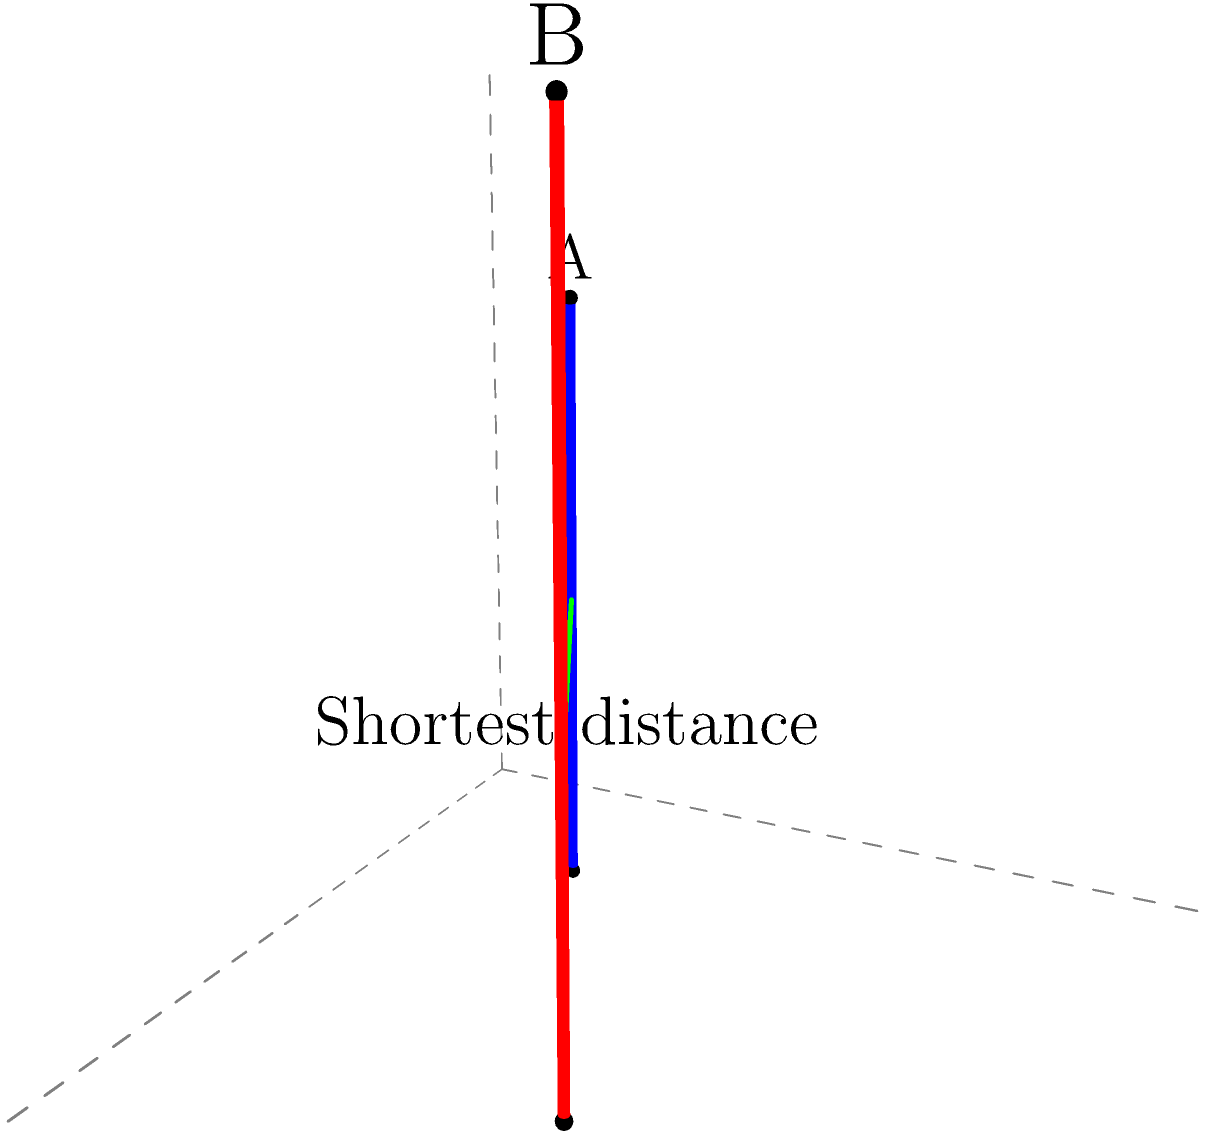Two skyscrapers, A and B, are represented as vertical line segments in a 3D coordinate system. Skyscraper A extends from $(1,1,0)$ to $(1,1,3)$, while skyscraper B extends from $(3,2,0)$ to $(3,2,4)$. What is the shortest distance between these two skyscrapers? To find the shortest distance between two vertical line segments in 3D space, we can follow these steps:

1) The shortest distance between two vertical line segments will always be horizontal, forming a right angle with both segments.

2) We can project the line segments onto the xy-plane, reducing the problem to 2D.

3) In the xy-plane, skyscraper A is at point $(1,1)$ and skyscraper B is at point $(3,2)$.

4) We can find the distance between these points using the distance formula:

   $$d = \sqrt{(x_2-x_1)^2 + (y_2-y_1)^2}$$

   $$d = \sqrt{(3-1)^2 + (2-1)^2} = \sqrt{4 + 1} = \sqrt{5}$$

5) This distance is the same regardless of the z-coordinate, so it represents the shortest distance between the skyscrapers.

Therefore, the shortest distance between the two skyscrapers is $\sqrt{5}$ units.
Answer: $\sqrt{5}$ units 